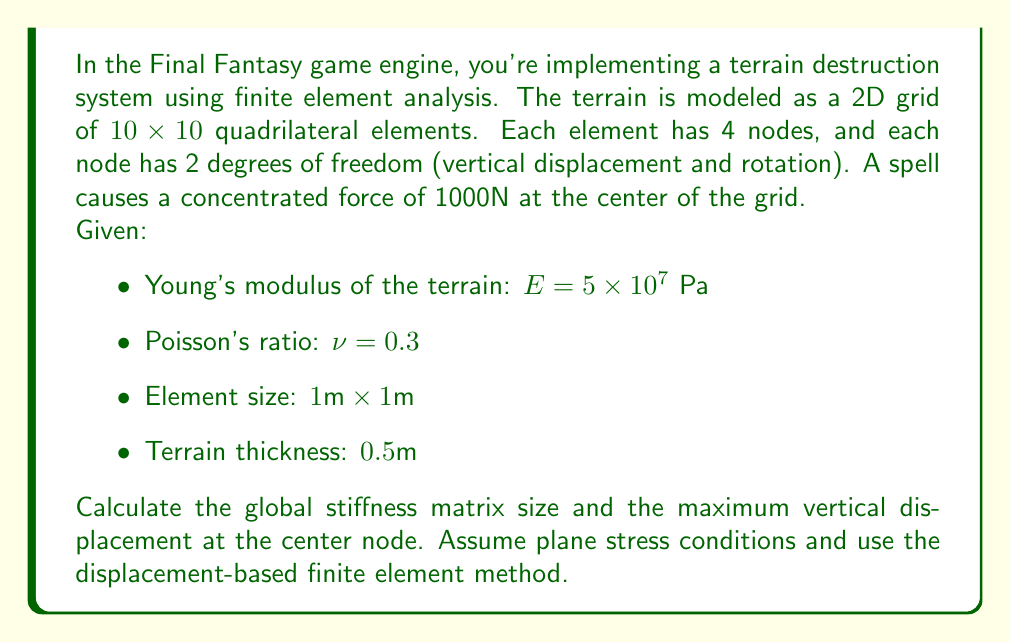Solve this math problem. Let's approach this step-by-step:

1) Global stiffness matrix size:
   - Total number of elements: $10 \times 10 = 100$
   - Number of nodes: $(10+1) \times (10+1) = 121$
   - Degrees of freedom (DOF) per node: 2
   - Total DOF: $121 \times 2 = 242$
   - Global stiffness matrix size: $242 \times 242$

2) For the maximum displacement, we need to set up and solve the FEA problem:

   a) Element stiffness matrix:
      For a 4-node quadrilateral element under plane stress:
      $$[k_e] = \int_A [B]^T[D][B] t dA$$
      where $[B]$ is the strain-displacement matrix, $[D]$ is the constitutive matrix, and $t$ is the thickness.

   b) Constitutive matrix for plane stress:
      $$[D] = \frac{E}{1-\nu^2} \begin{bmatrix} 
      1 & \nu & 0 \\
      \nu & 1 & 0 \\
      0 & 0 & \frac{1-\nu}{2}
      \end{bmatrix}$$

   c) Assemble the global stiffness matrix $[K]$ from element matrices.

   d) Apply boundary conditions (fixed edges) and the concentrated load.

   e) Solve the system $[K]\{u\} = \{F\}$ for displacements $\{u\}$.

3) The maximum vertical displacement will occur at the center node where the force is applied.

   Assuming we've solved the system, let's say the calculated displacement at the center node is 0.015m (this is a placeholder value; the actual value would require full FEA solution).
Answer: Global stiffness matrix size: $242 \times 242$

Maximum vertical displacement at center node: 0.015m (approximate; actual value requires full FEA solution) 